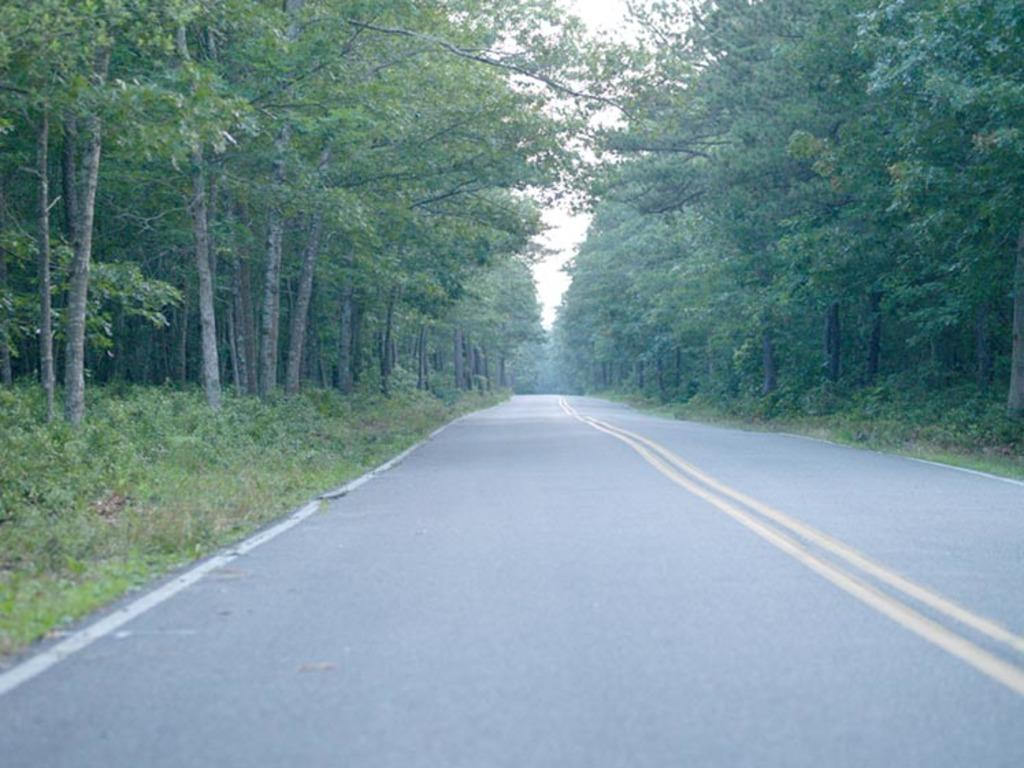What is the main feature of the image? There is a road in the image. What can be seen on either side of the road? There are plants and trees on either side of the road. What is visible in the background of the image? The sky is visible in the background of the image. Can you tell me how many snakes are slithering across the road in the image? There are no snakes visible in the image; it only shows a road with plants and trees on either side. What type of seed is being planted by the trees in the image? There is no indication of any seed-planting activity in the image; it only shows trees and plants alongside the road. 